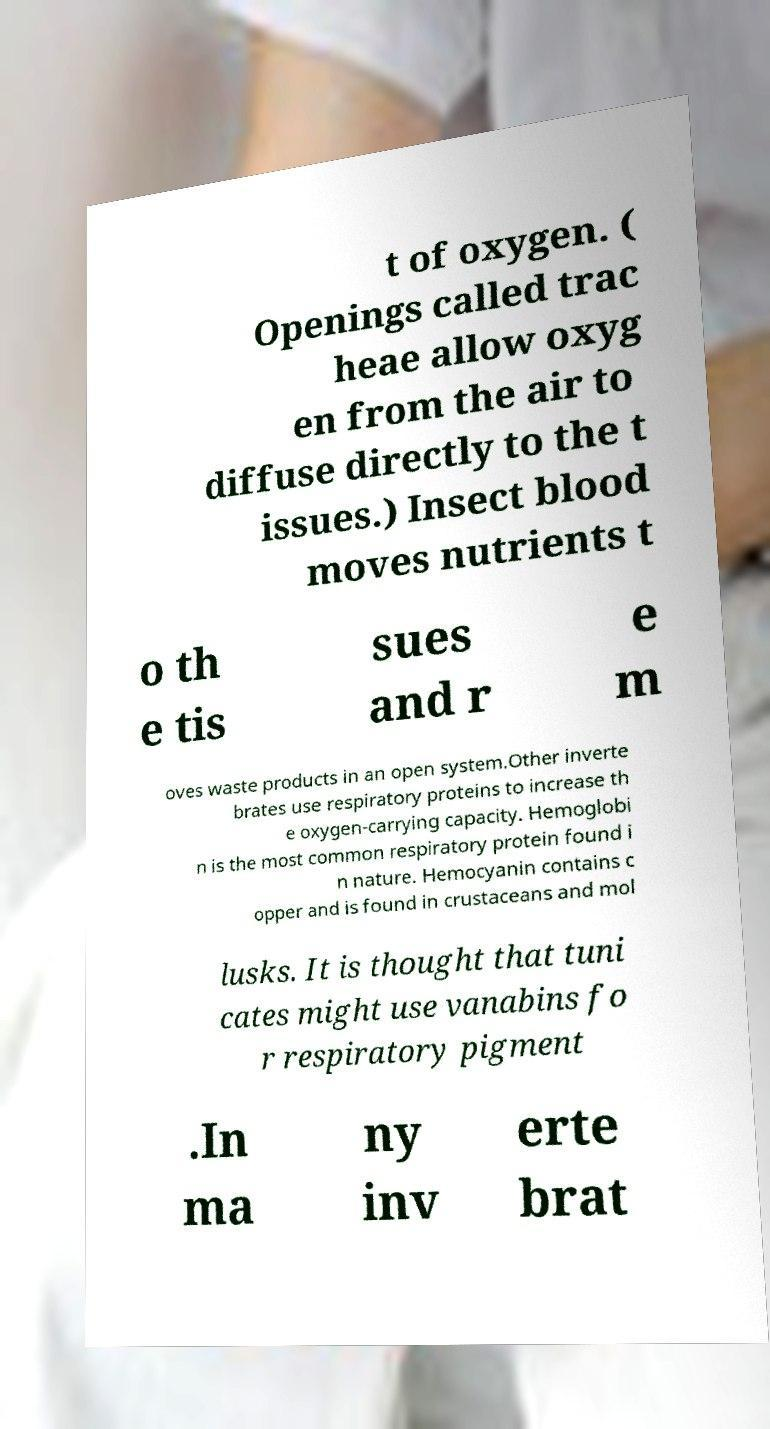Could you assist in decoding the text presented in this image and type it out clearly? t of oxygen. ( Openings called trac heae allow oxyg en from the air to diffuse directly to the t issues.) Insect blood moves nutrients t o th e tis sues and r e m oves waste products in an open system.Other inverte brates use respiratory proteins to increase th e oxygen-carrying capacity. Hemoglobi n is the most common respiratory protein found i n nature. Hemocyanin contains c opper and is found in crustaceans and mol lusks. It is thought that tuni cates might use vanabins fo r respiratory pigment .In ma ny inv erte brat 